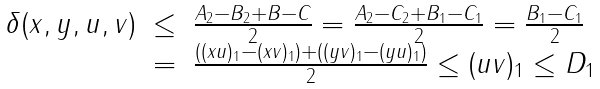Convert formula to latex. <formula><loc_0><loc_0><loc_500><loc_500>\begin{array} { c l l } \delta ( x , y , u , v ) & \leq & \frac { A _ { 2 } - B _ { 2 } + B - C } { 2 } = \frac { A _ { 2 } - C _ { 2 } + B _ { 1 } - C _ { 1 } } { 2 } = \frac { B _ { 1 } - C _ { 1 } } { 2 } \\ & = & \frac { ( ( x u ) _ { 1 } - ( x v ) _ { 1 } ) + ( ( y v ) _ { 1 } - ( y u ) _ { 1 } ) } { 2 } \leq ( u v ) _ { 1 } \leq D _ { 1 } \end{array}</formula> 